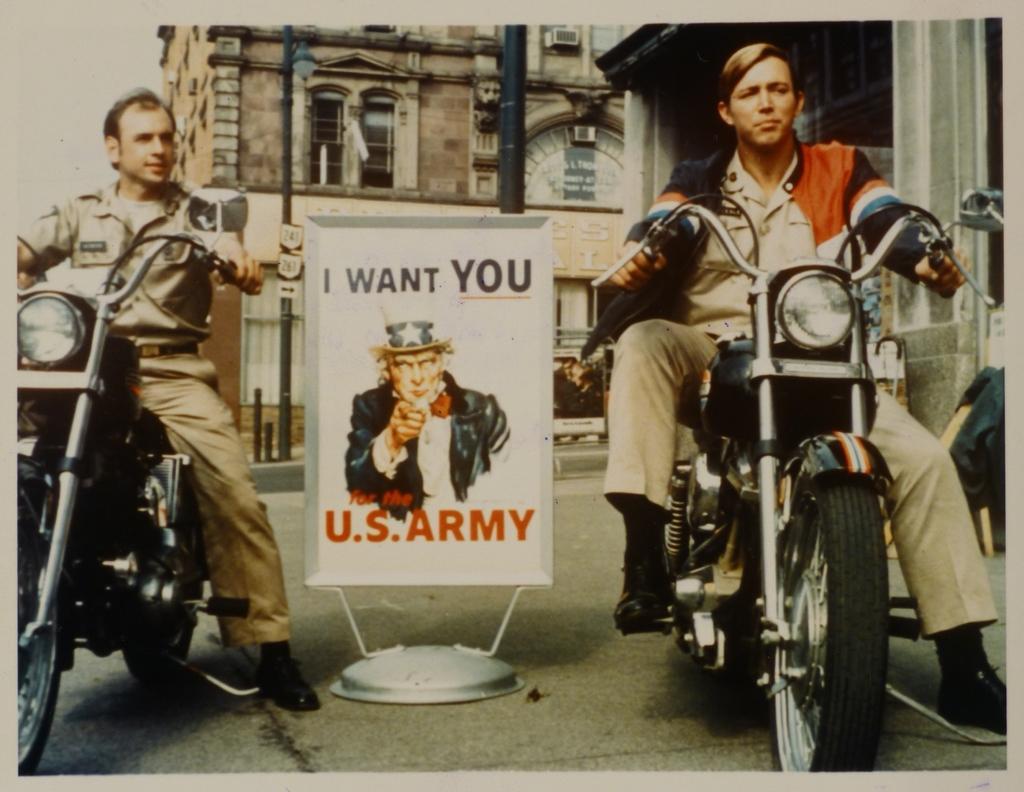How would you summarize this image in a sentence or two? In this picture two guys are sitting on a bike and between them there is a poster named I WANT YOU US ARMY. There are buildings in the background. 